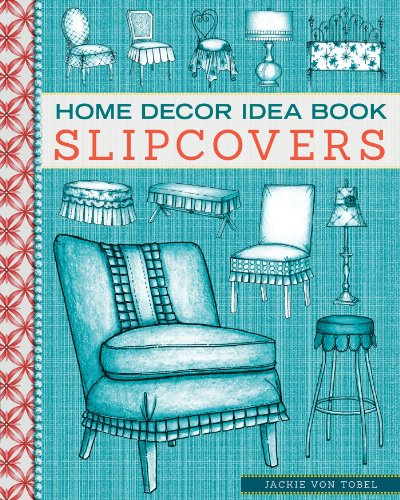What type of book is this? This book belongs to the 'Crafts, Hobbies & Home' category, focusing specifically on unique DIY ideas and techniques for upholstery and fabric work in home decor. 